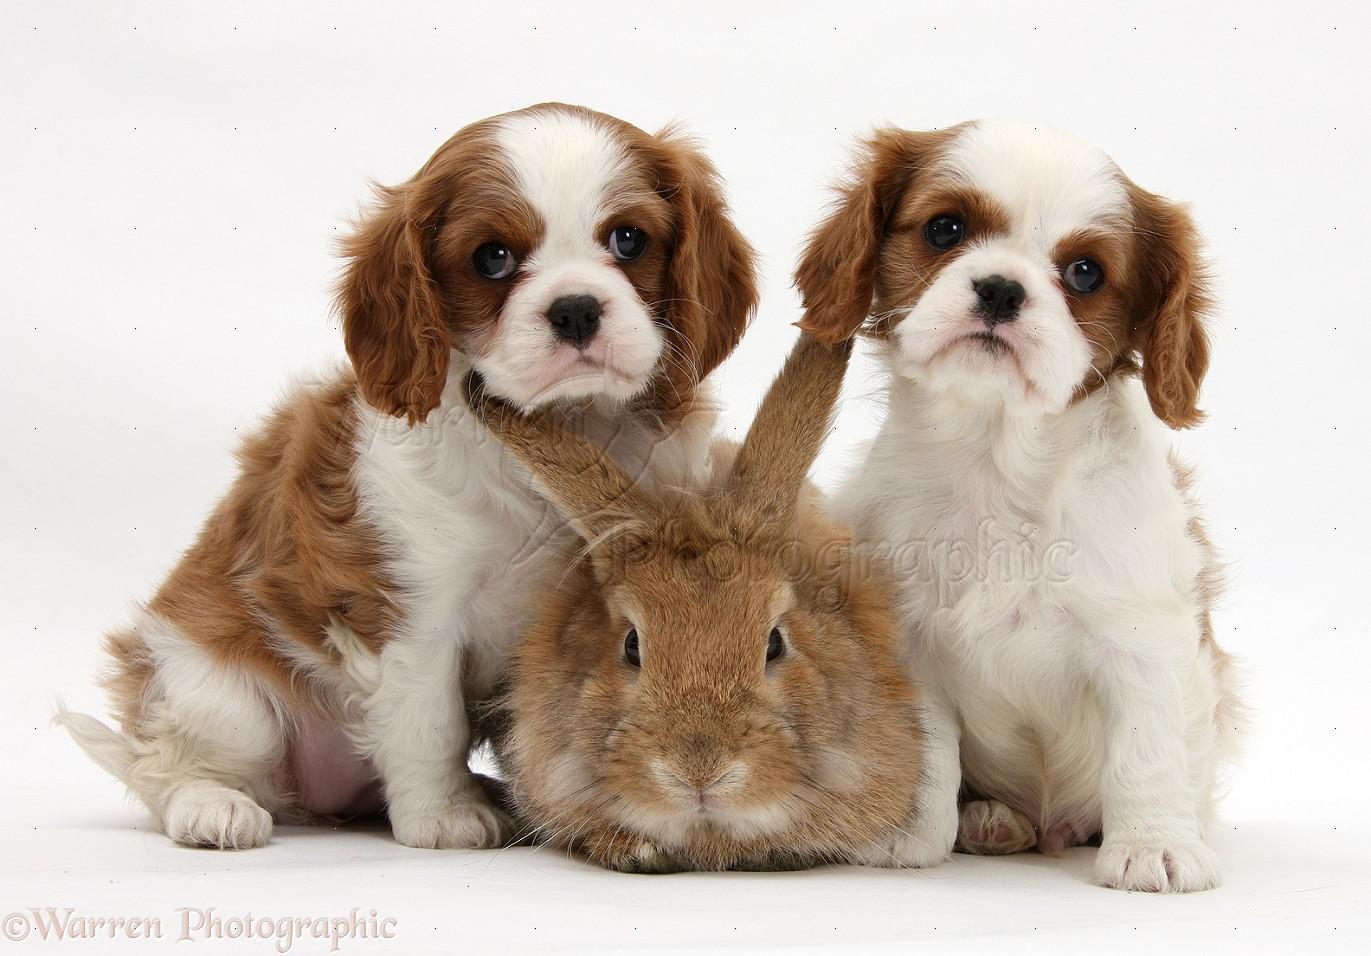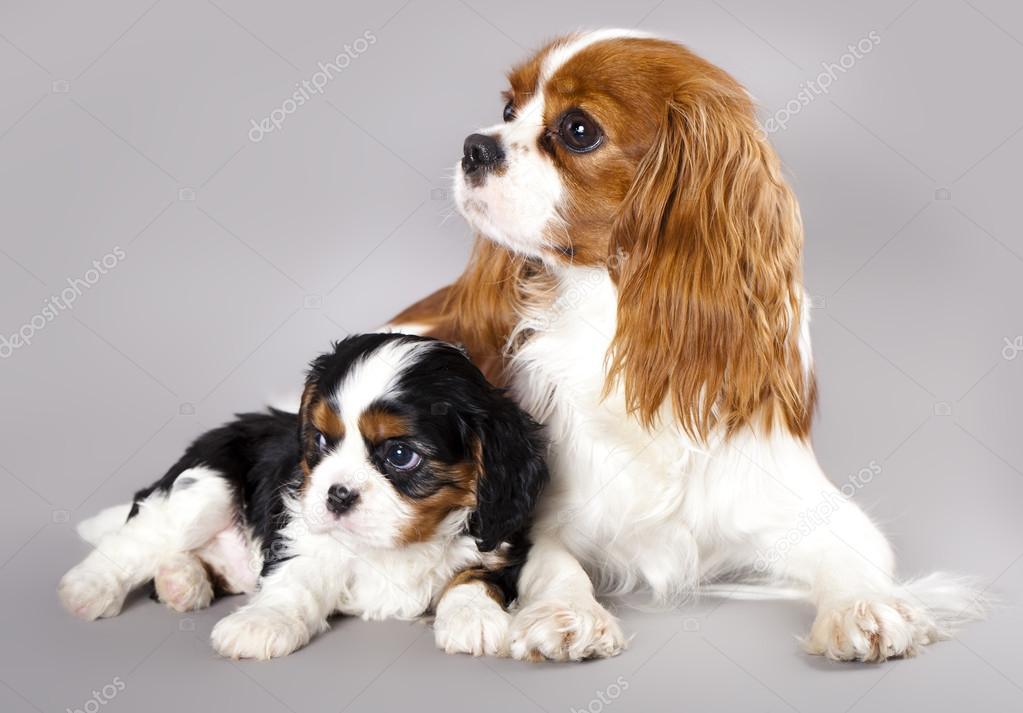The first image is the image on the left, the second image is the image on the right. Analyze the images presented: Is the assertion "One of the images shows an inanimate object with the dog." valid? Answer yes or no. No. 